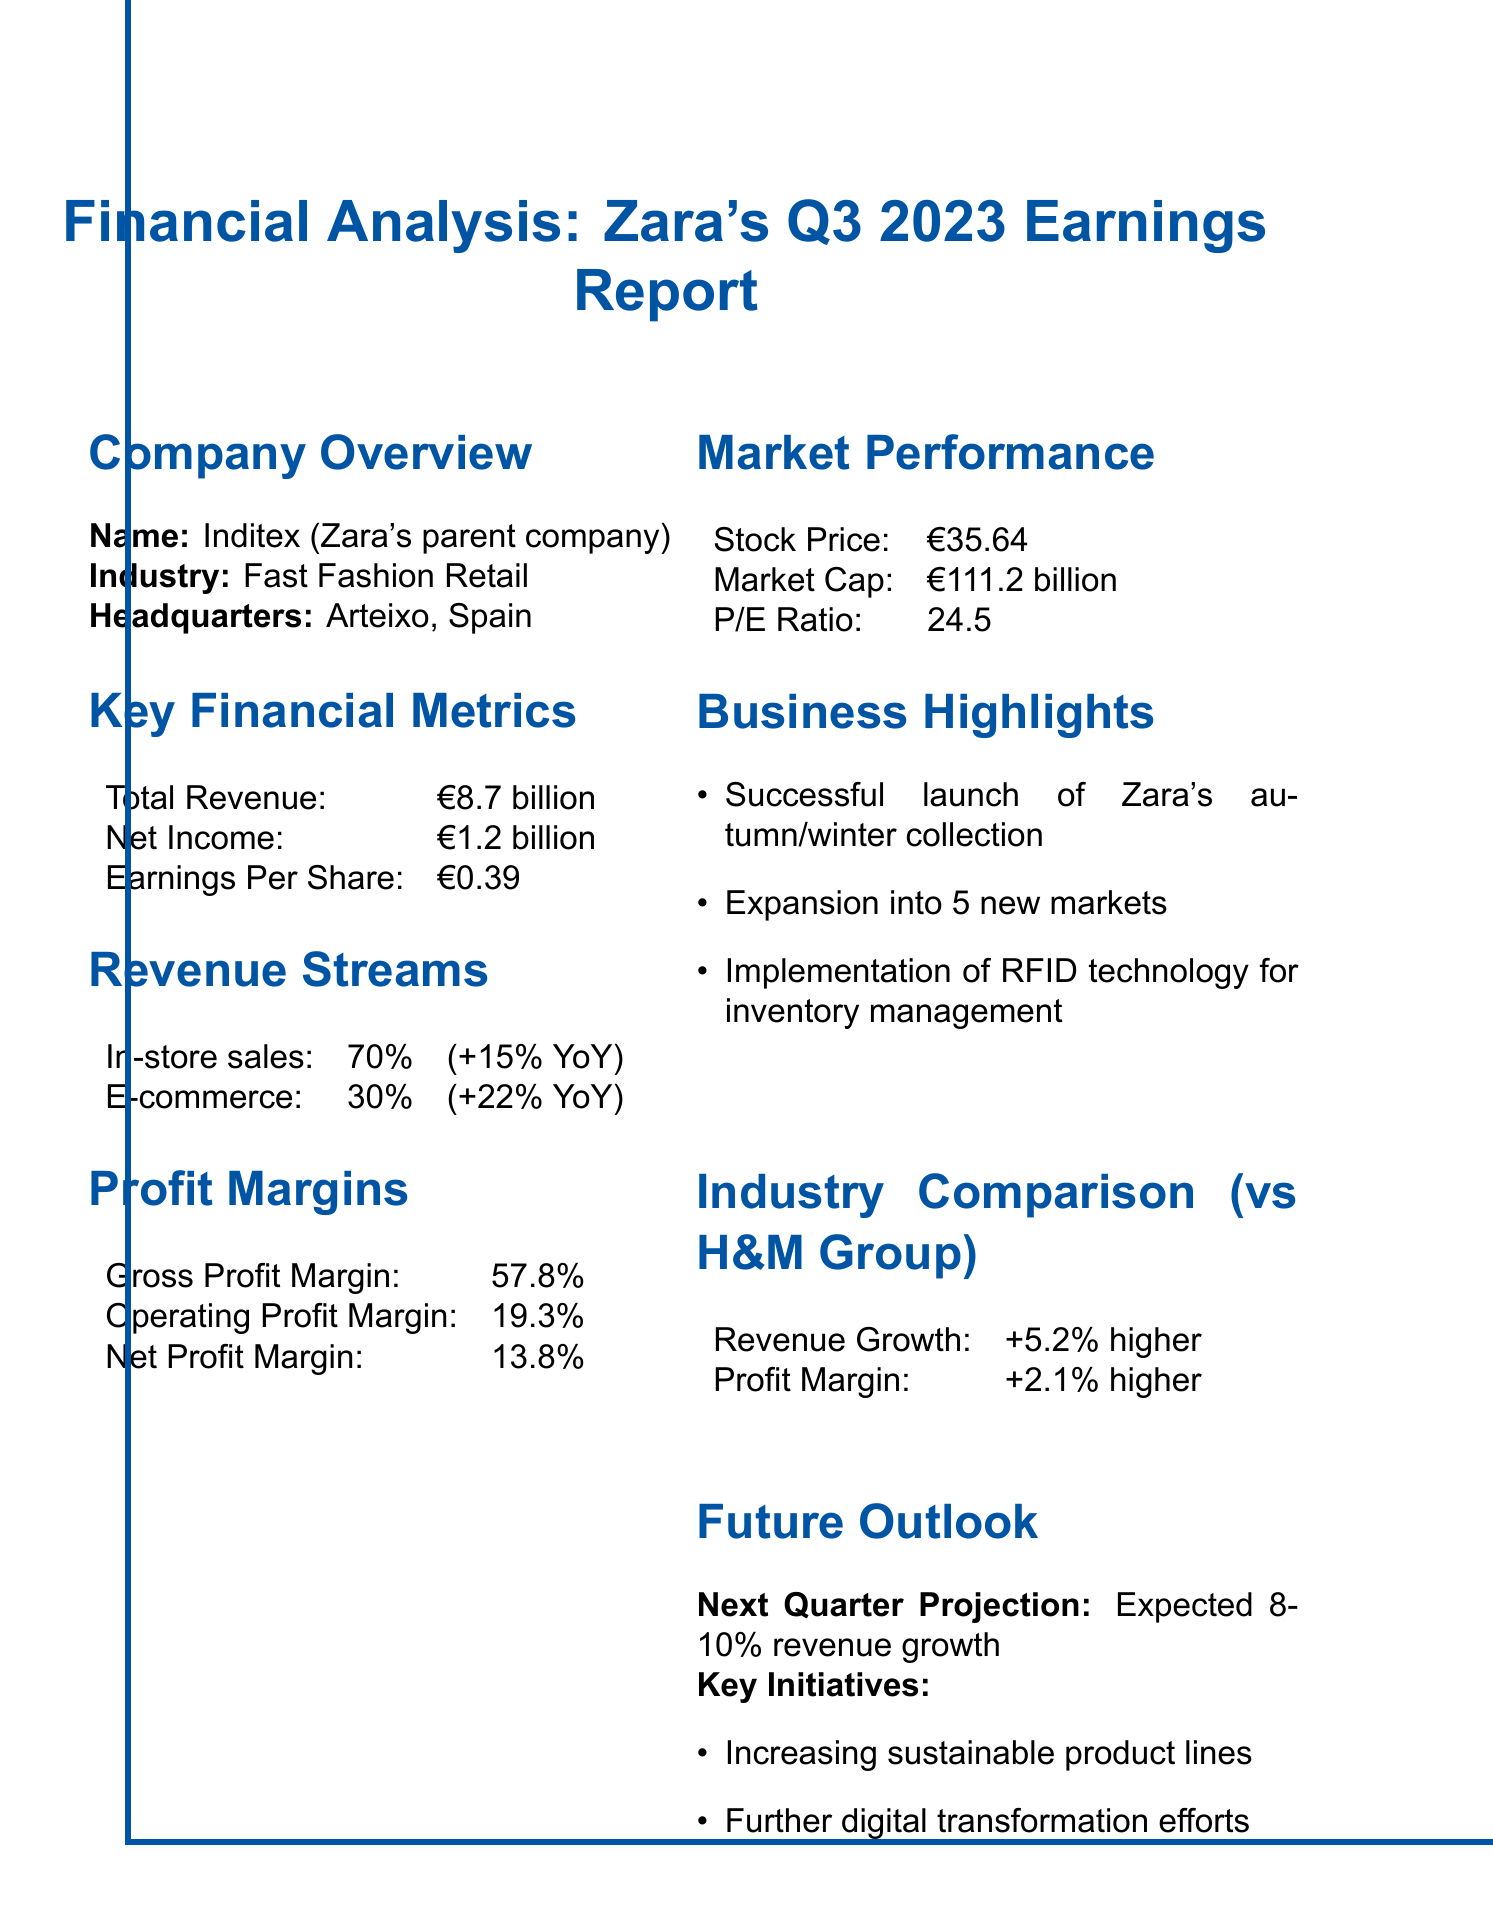what is Zara's total revenue in Q3 2023? The total revenue listed in the report is specifically mentioned under Key Financial Metrics.
Answer: €8.7 billion what is the net income reported for Zara in Q3 2023? Net income is a key financial metric that indicates the profit after all expenses are deducted, found under Key Financial Metrics.
Answer: €1.2 billion what is the gross profit margin of Zara? Gross profit margin is provided as a key profitability metric in the Profit Margins section of the report.
Answer: 57.8% how much did e-commerce sales grow year-over-year? The growth percentage for e-commerce is provided in the Revenue Streams section, indicating its performance.
Answer: +22% YoY what was the stock price of Zara on the market? The stock price is highlighted under the Market Performance section of the report, indicating current trading value.
Answer: €35.64 how does Zara's revenue growth compare to H&M Group? This comparison is provided in the Industry Comparison section, which evaluates Zara against a key competitor.
Answer: +5.2% higher what sustainable initiatives is Zara planning for the future? Future outlook initiatives are specified in the Future Outlook section, detailing the company's commitments moving forward.
Answer: Increasing sustainable product lines what was a key highlight from Zara's recent business activities? Key business highlights are outlined in the Business Highlights section of the report, showcasing major achievements.
Answer: Successful launch of Zara's autumn/winter collection what is the expected revenue growth for the next quarter? The projection for the next quarter is described under Future Outlook, indicating anticipated performance.
Answer: 8-10% revenue growth 